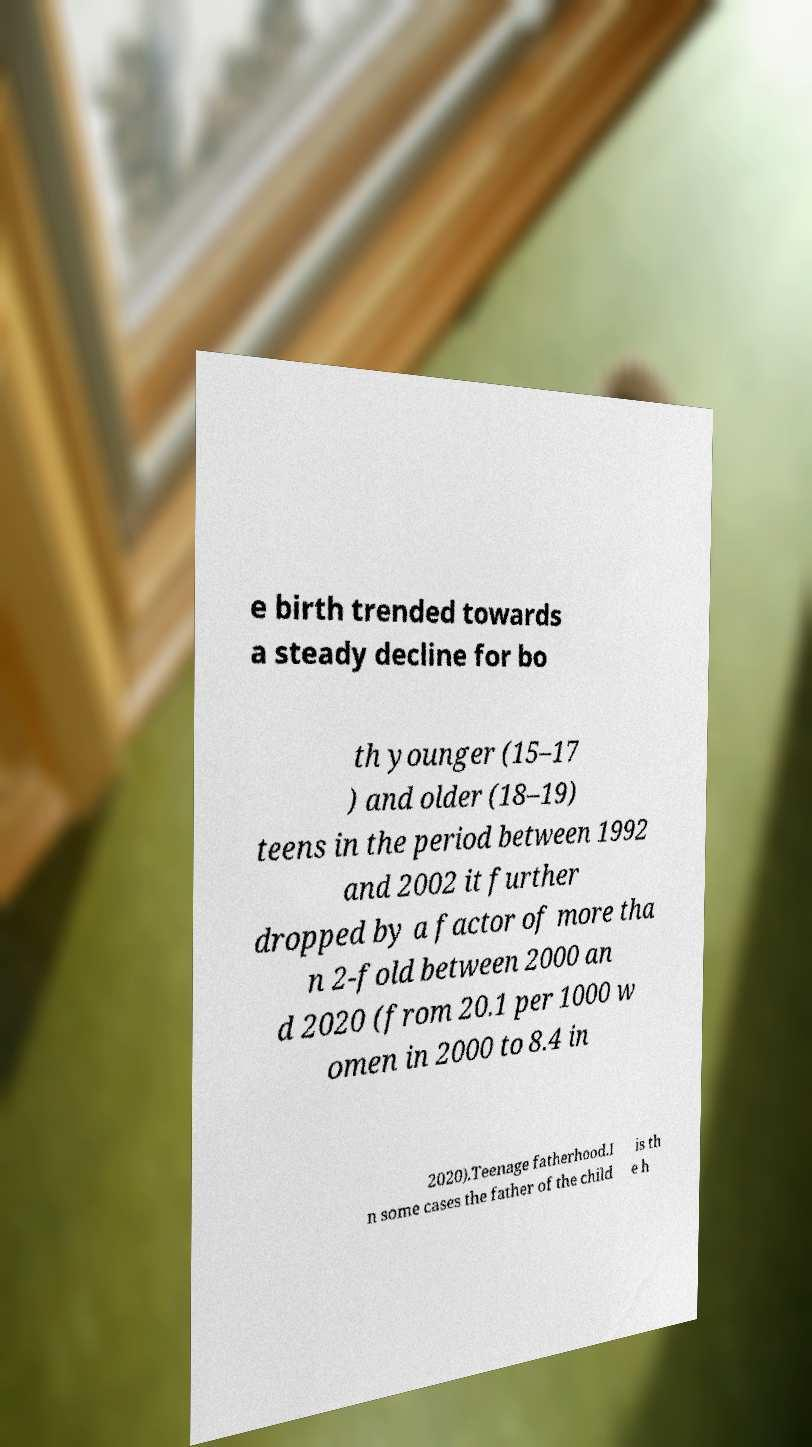Could you extract and type out the text from this image? e birth trended towards a steady decline for bo th younger (15–17 ) and older (18–19) teens in the period between 1992 and 2002 it further dropped by a factor of more tha n 2-fold between 2000 an d 2020 (from 20.1 per 1000 w omen in 2000 to 8.4 in 2020).Teenage fatherhood.I n some cases the father of the child is th e h 